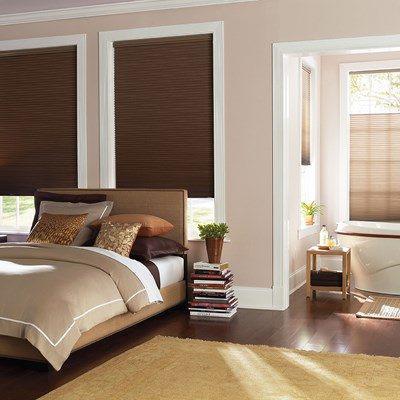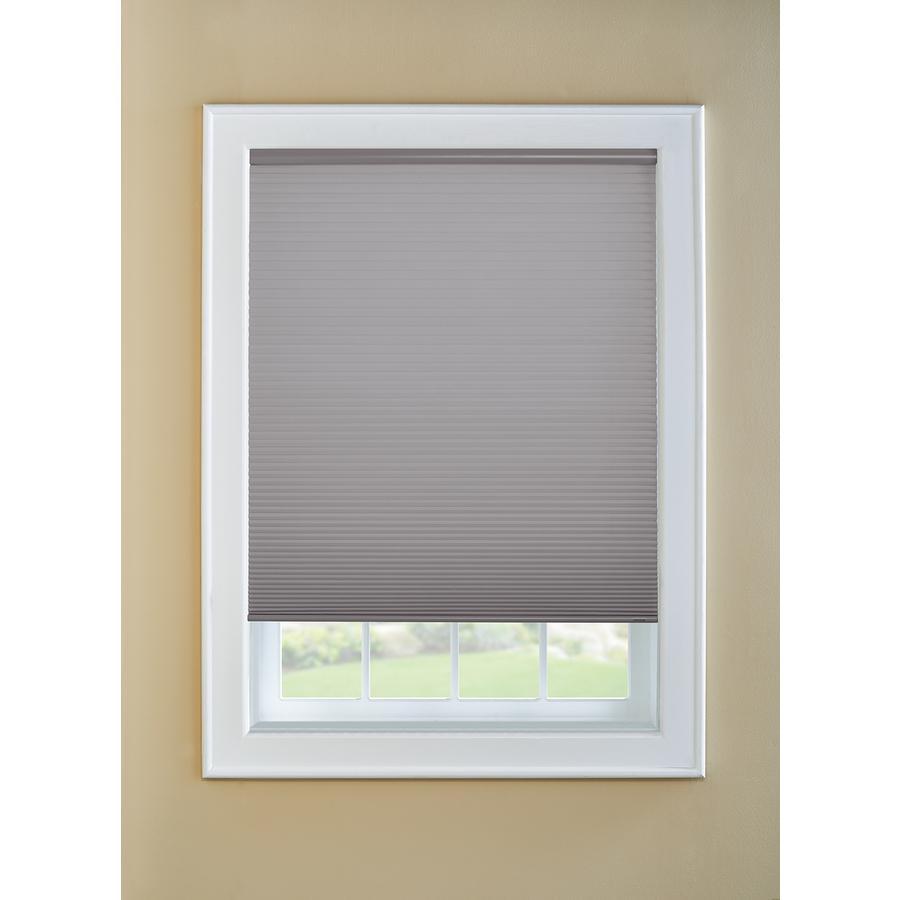The first image is the image on the left, the second image is the image on the right. Given the left and right images, does the statement "There are shaded windows near the sofas." hold true? Answer yes or no. No. 